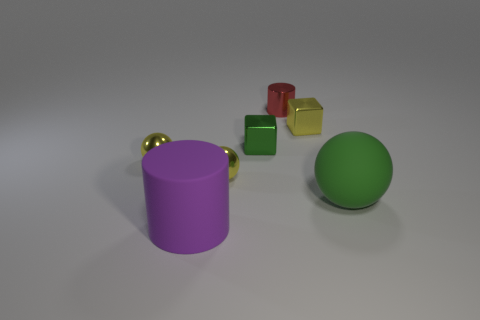There is a thing that is to the right of the red thing and behind the green shiny object; what is its material?
Your answer should be compact. Metal. How many small objects are either green matte things or red metallic things?
Offer a terse response. 1. What is the size of the rubber cylinder?
Keep it short and to the point. Large. What shape is the big green rubber thing?
Keep it short and to the point. Sphere. Is there anything else that has the same shape as the red object?
Give a very brief answer. Yes. Is the number of small objects that are left of the tiny shiny cylinder less than the number of tiny yellow blocks?
Offer a terse response. No. Is the color of the big rubber object that is to the left of the red cylinder the same as the tiny cylinder?
Ensure brevity in your answer.  No. How many metal objects are tiny spheres or large purple cylinders?
Provide a succinct answer. 2. Is there anything else that is the same size as the rubber cylinder?
Keep it short and to the point. Yes. There is a object that is the same material as the large cylinder; what is its color?
Offer a terse response. Green. 